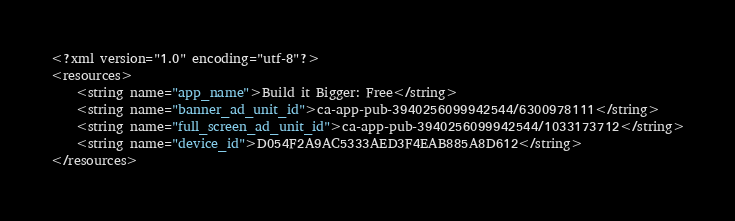Convert code to text. <code><loc_0><loc_0><loc_500><loc_500><_XML_><?xml version="1.0" encoding="utf-8"?>
<resources>
    <string name="app_name">Build it Bigger: Free</string>
    <string name="banner_ad_unit_id">ca-app-pub-3940256099942544/6300978111</string>
    <string name="full_screen_ad_unit_id">ca-app-pub-3940256099942544/1033173712</string>
    <string name="device_id">D054F2A9AC5333AED3F4EAB885A8D612</string>
</resources></code> 